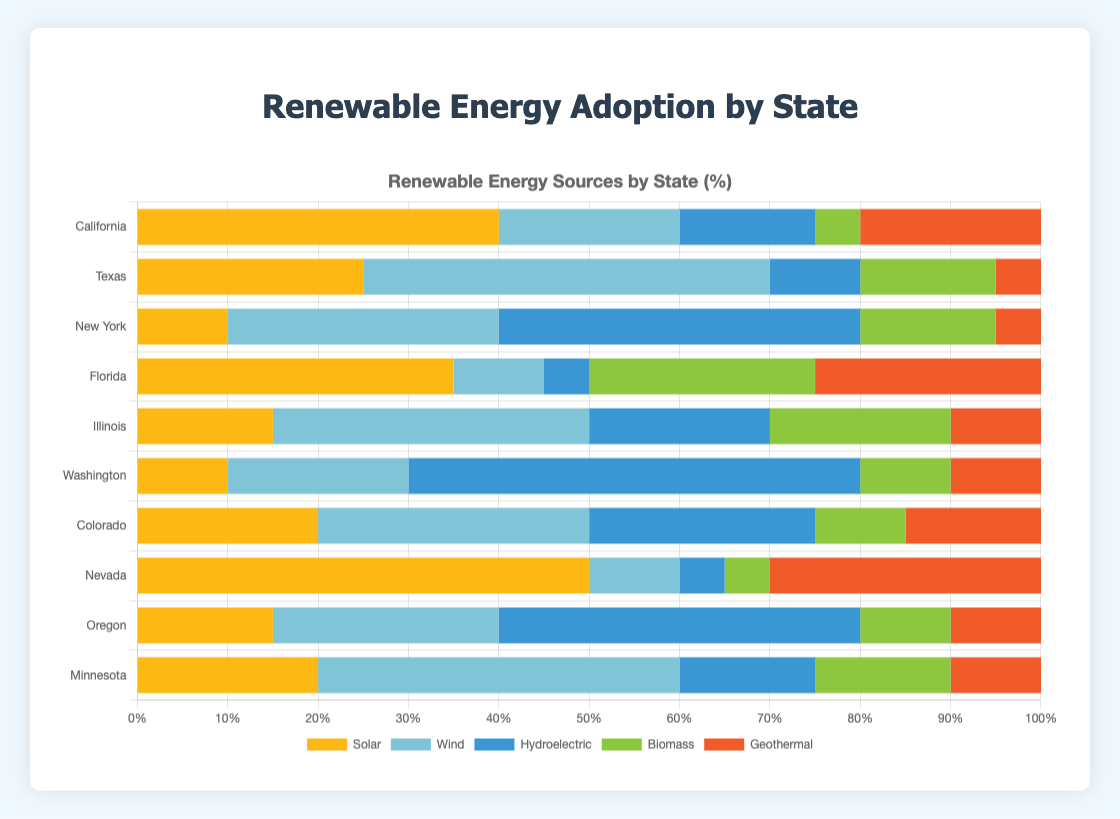What are the two largest renewable energy sources in California and their combined percentage? The largest renewable energy source in California is Solar with 40%, followed by Geothermal with 20%. The combined percentage of these two sources is 40% + 20% = 60%
Answer: Solar and Geothermal, 60% Which state has the highest percentage of Wind energy? By reviewing the bars for Wind energy in each state, Texas has the highest percentage of Wind energy with 45%
Answer: Texas How does Nevada's adoption of Solar energy compare to Minnesota's? Nevada has a Solar energy adoption of 50%, while Minnesota has 20%. So, Nevada's Solar energy adoption is higher by 50% - 20% = 30%
Answer: Nevada's Solar energy adoption is 30% higher Which two states have the same percentage of Geothermal energy, and what is it? Using color identifier, both Washington and Illinois have equal-length bars for Geothermal energy, which is 10% each
Answer: Washington and Illinois, 10% If you sum up the percentage of Biomass and Hydroelectric energy in Illinois, what do you get? The percentage for Biomass is 20% and Hydroelectric is 20% in Illinois. Summing these two gives 20% + 20% = 40%
Answer: 40% Which state has the highest overall percentage of renewable energy from Biomass? By comparing the Biomass energy bars across states, Florida has the highest percentage at 25%
Answer: Florida What is the total percentage of renewable energy from Wind and Geothermal sources in Oregon? In Oregon, Wind contributes 25% and Geothermal contributes 10%. The total is 25% + 10% = 35%
Answer: 35% How much more does Solar energy contribute in Nevada compared to Hydroelectric in Colorado? In Nevada, Solar energy contributes 50%, while in Colorado, Hydroelectric contributes 25%. The difference is 50% - 25% = 25%
Answer: 25% Is there any state where the percentage of Solar energy is less than the percentage of Wind energy? If yes, name one. Yes, New York has 10% Solar energy and 30% Wind energy
Answer: New York 